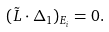<formula> <loc_0><loc_0><loc_500><loc_500>( \tilde { L } \cdot \Delta _ { 1 } ) _ { E _ { i } } = 0 .</formula> 